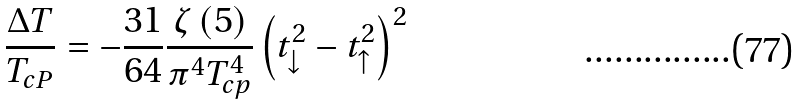Convert formula to latex. <formula><loc_0><loc_0><loc_500><loc_500>\frac { \Delta T } { T _ { c P } } = - \frac { 3 1 } { 6 4 } \frac { \zeta \left ( 5 \right ) } { \pi ^ { 4 } T _ { c p } ^ { 4 } } \left ( t _ { \downarrow } ^ { 2 } - t _ { \uparrow } ^ { 2 } \right ) ^ { 2 }</formula> 